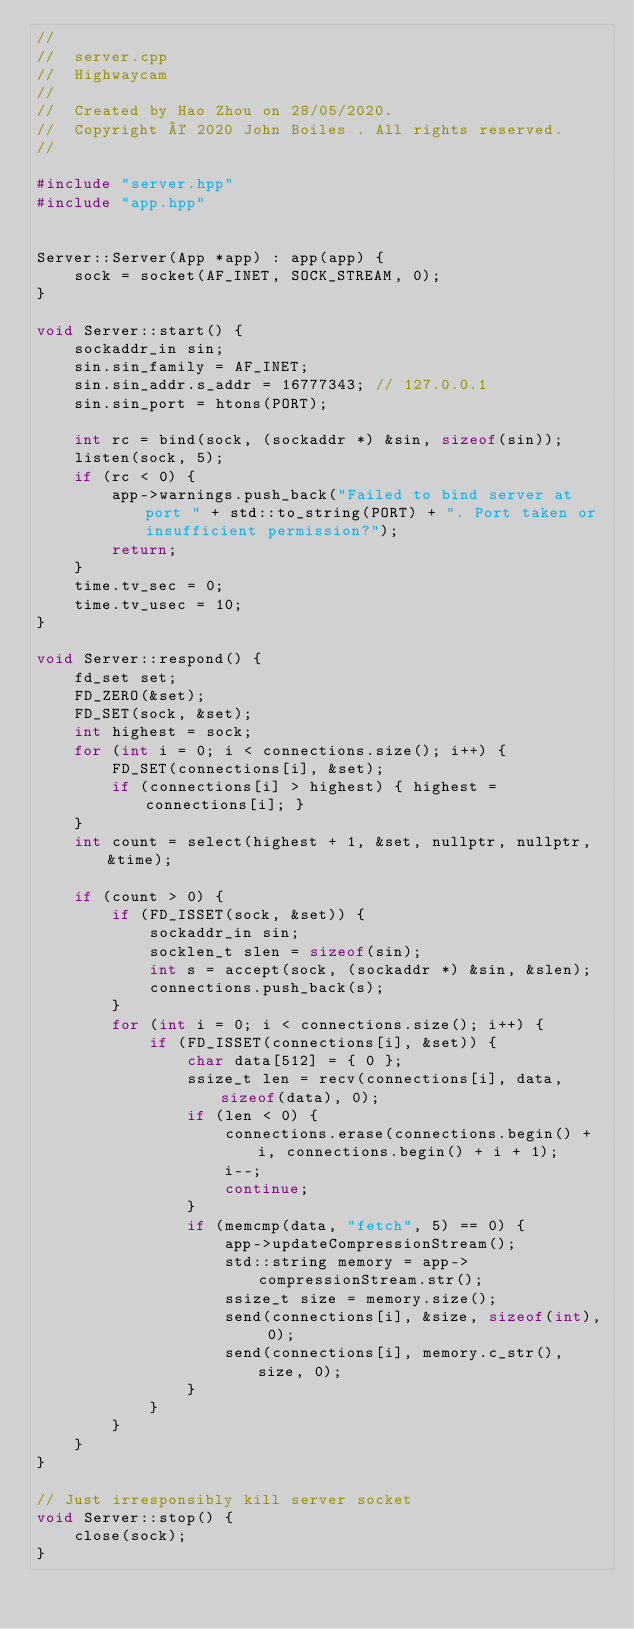<code> <loc_0><loc_0><loc_500><loc_500><_C++_>//
//  server.cpp
//  Highwaycam
//
//  Created by Hao Zhou on 28/05/2020.
//  Copyright © 2020 John Boiles . All rights reserved.
//

#include "server.hpp"
#include "app.hpp"


Server::Server(App *app) : app(app) {
    sock = socket(AF_INET, SOCK_STREAM, 0);
}

void Server::start() { 
    sockaddr_in sin;
    sin.sin_family = AF_INET;
    sin.sin_addr.s_addr = 16777343; // 127.0.0.1
    sin.sin_port = htons(PORT);
    
    int rc = bind(sock, (sockaddr *) &sin, sizeof(sin));
    listen(sock, 5);
    if (rc < 0) {
        app->warnings.push_back("Failed to bind server at port " + std::to_string(PORT) + ". Port taken or insufficient permission?");
        return;
    }
    time.tv_sec = 0;
    time.tv_usec = 10;
}

void Server::respond() { 
    fd_set set;
    FD_ZERO(&set);
    FD_SET(sock, &set);
    int highest = sock;
    for (int i = 0; i < connections.size(); i++) {
        FD_SET(connections[i], &set);
        if (connections[i] > highest) { highest = connections[i]; }
    }
    int count = select(highest + 1, &set, nullptr, nullptr, &time);

    if (count > 0) {
        if (FD_ISSET(sock, &set)) {
            sockaddr_in sin;
            socklen_t slen = sizeof(sin);
            int s = accept(sock, (sockaddr *) &sin, &slen);
            connections.push_back(s);
        }
        for (int i = 0; i < connections.size(); i++) {
            if (FD_ISSET(connections[i], &set)) {
                char data[512] = { 0 };
                ssize_t len = recv(connections[i], data, sizeof(data), 0);
                if (len < 0) {
                    connections.erase(connections.begin() + i, connections.begin() + i + 1);
                    i--;
                    continue;
                }
                if (memcmp(data, "fetch", 5) == 0) {
                    app->updateCompressionStream();
                    std::string memory = app->compressionStream.str();
                    ssize_t size = memory.size();
                    send(connections[i], &size, sizeof(int), 0);
                    send(connections[i], memory.c_str(), size, 0);
                }
            }
        }
    }
}

// Just irresponsibly kill server socket
void Server::stop() {
    close(sock);
}
</code> 